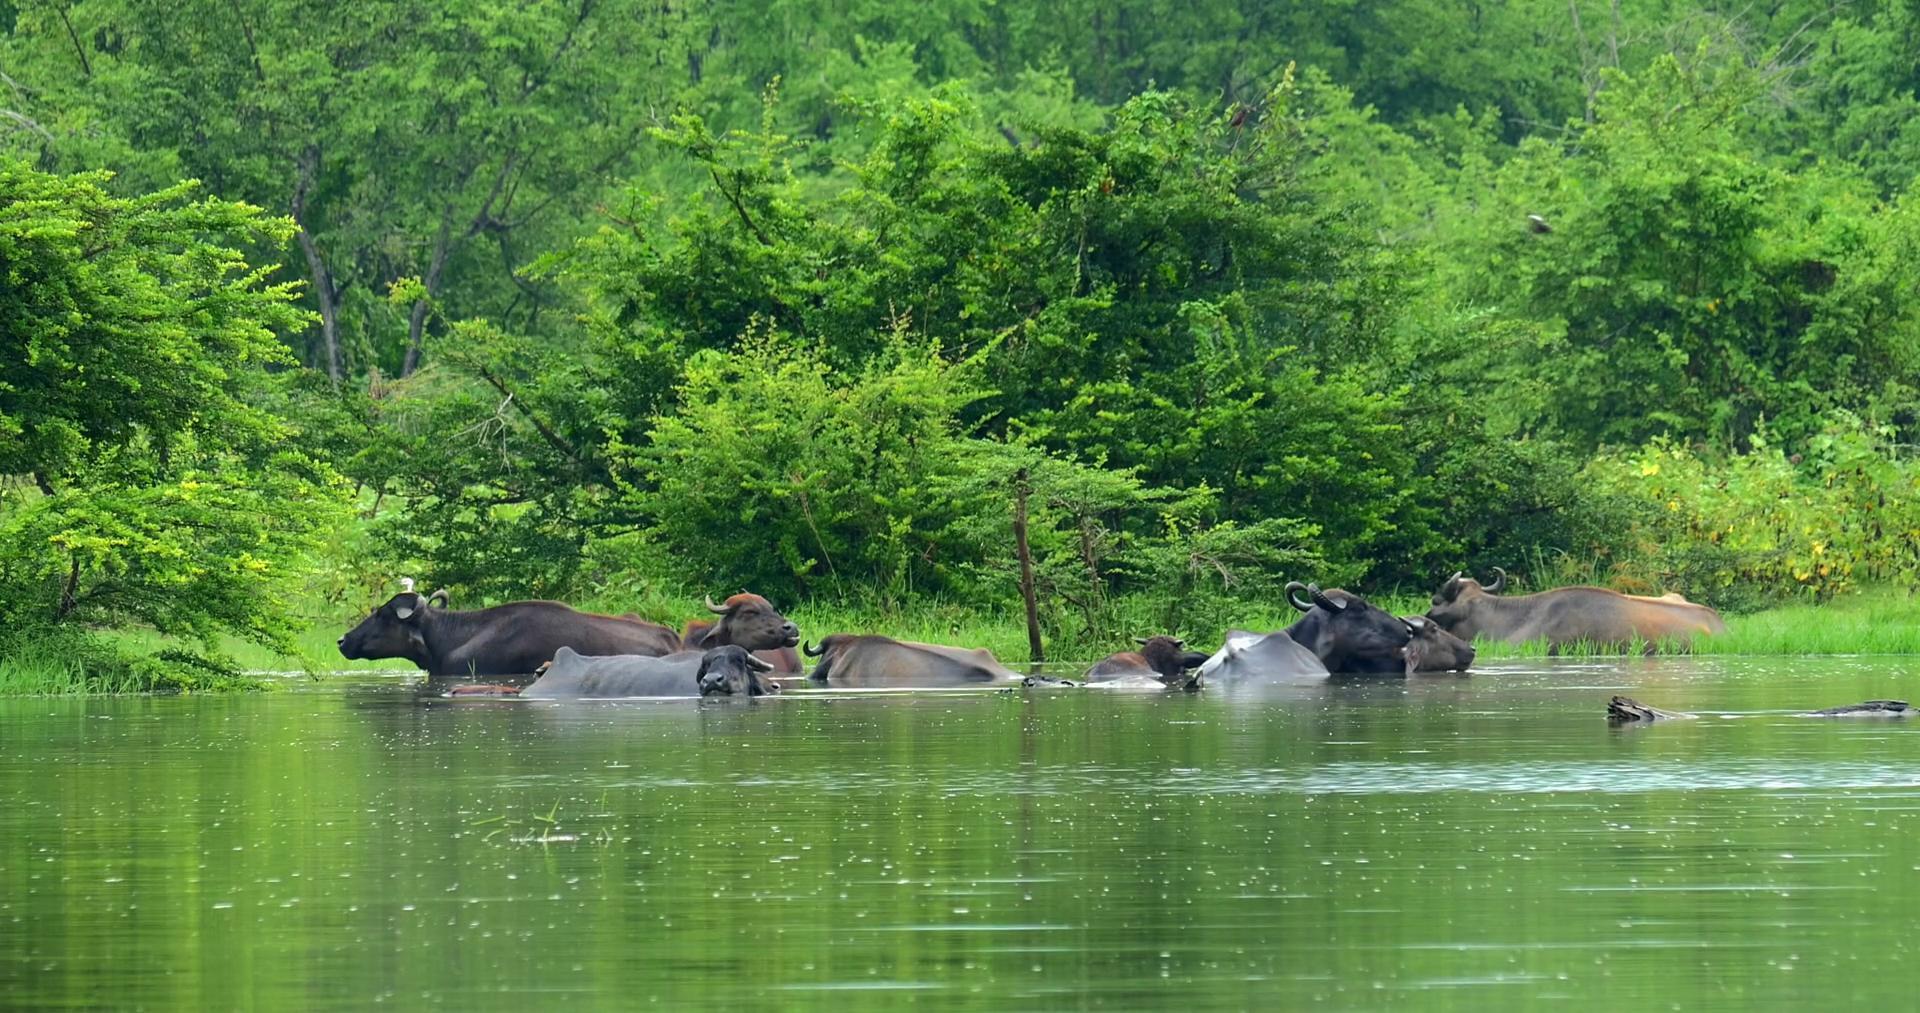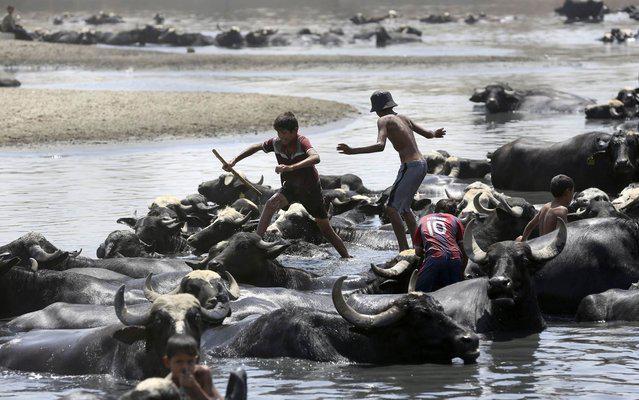The first image is the image on the left, the second image is the image on the right. For the images shown, is this caption "One the left image there is only one water buffalo." true? Answer yes or no. No. The first image is the image on the left, the second image is the image on the right. Given the left and right images, does the statement "All images show water buffalo in the water, and one image shows at least one young male in the scene with water buffalo." hold true? Answer yes or no. Yes. 